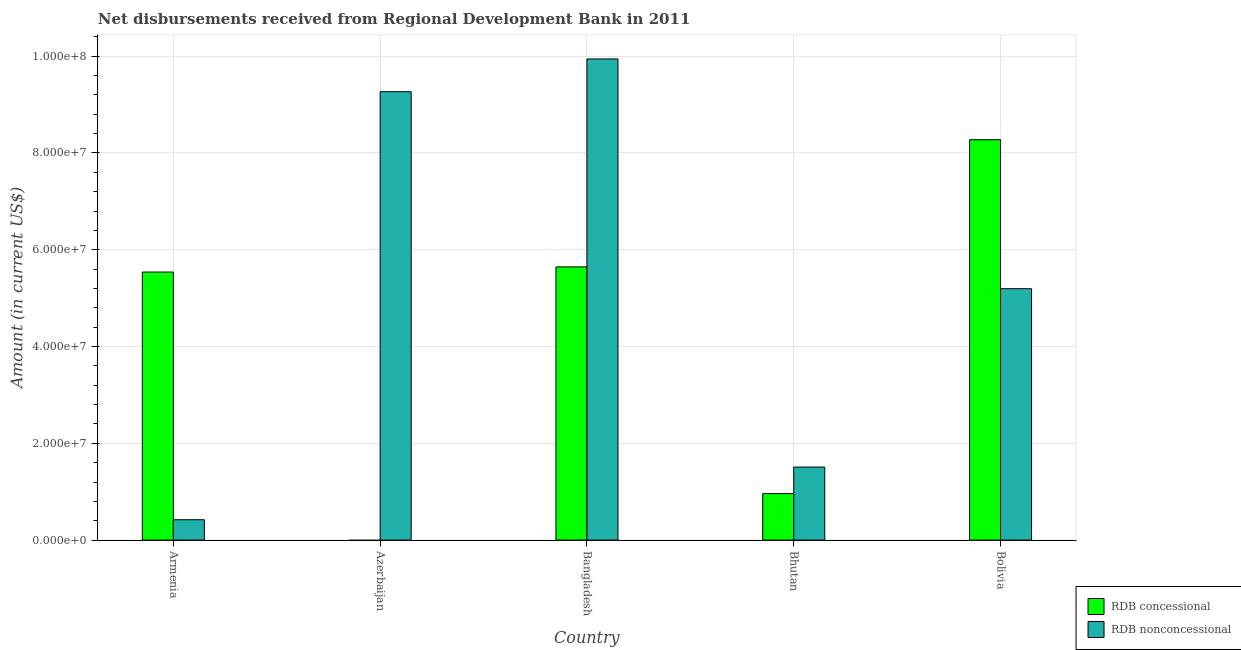How many different coloured bars are there?
Keep it short and to the point. 2. Are the number of bars per tick equal to the number of legend labels?
Your response must be concise. No. Are the number of bars on each tick of the X-axis equal?
Ensure brevity in your answer.  No. What is the label of the 2nd group of bars from the left?
Provide a succinct answer. Azerbaijan. In how many cases, is the number of bars for a given country not equal to the number of legend labels?
Ensure brevity in your answer.  1. What is the net concessional disbursements from rdb in Bolivia?
Give a very brief answer. 8.27e+07. Across all countries, what is the maximum net non concessional disbursements from rdb?
Give a very brief answer. 9.94e+07. What is the total net concessional disbursements from rdb in the graph?
Your response must be concise. 2.04e+08. What is the difference between the net concessional disbursements from rdb in Armenia and that in Bangladesh?
Ensure brevity in your answer.  -1.06e+06. What is the difference between the net non concessional disbursements from rdb in Bolivia and the net concessional disbursements from rdb in Bhutan?
Your answer should be compact. 4.23e+07. What is the average net concessional disbursements from rdb per country?
Give a very brief answer. 4.08e+07. What is the difference between the net concessional disbursements from rdb and net non concessional disbursements from rdb in Bolivia?
Your answer should be very brief. 3.08e+07. In how many countries, is the net non concessional disbursements from rdb greater than 96000000 US$?
Give a very brief answer. 1. What is the ratio of the net non concessional disbursements from rdb in Armenia to that in Bolivia?
Ensure brevity in your answer.  0.08. What is the difference between the highest and the second highest net concessional disbursements from rdb?
Ensure brevity in your answer.  2.63e+07. What is the difference between the highest and the lowest net non concessional disbursements from rdb?
Make the answer very short. 9.52e+07. In how many countries, is the net non concessional disbursements from rdb greater than the average net non concessional disbursements from rdb taken over all countries?
Make the answer very short. 2. Is the sum of the net concessional disbursements from rdb in Armenia and Bhutan greater than the maximum net non concessional disbursements from rdb across all countries?
Provide a short and direct response. No. How many bars are there?
Offer a very short reply. 9. What is the difference between two consecutive major ticks on the Y-axis?
Offer a very short reply. 2.00e+07. Does the graph contain any zero values?
Your response must be concise. Yes. Where does the legend appear in the graph?
Give a very brief answer. Bottom right. What is the title of the graph?
Give a very brief answer. Net disbursements received from Regional Development Bank in 2011. Does "Age 15+" appear as one of the legend labels in the graph?
Your answer should be compact. No. What is the label or title of the X-axis?
Ensure brevity in your answer.  Country. What is the Amount (in current US$) in RDB concessional in Armenia?
Provide a succinct answer. 5.54e+07. What is the Amount (in current US$) in RDB nonconcessional in Armenia?
Provide a short and direct response. 4.21e+06. What is the Amount (in current US$) of RDB nonconcessional in Azerbaijan?
Make the answer very short. 9.27e+07. What is the Amount (in current US$) in RDB concessional in Bangladesh?
Give a very brief answer. 5.64e+07. What is the Amount (in current US$) of RDB nonconcessional in Bangladesh?
Offer a terse response. 9.94e+07. What is the Amount (in current US$) of RDB concessional in Bhutan?
Make the answer very short. 9.62e+06. What is the Amount (in current US$) of RDB nonconcessional in Bhutan?
Your answer should be compact. 1.51e+07. What is the Amount (in current US$) of RDB concessional in Bolivia?
Your response must be concise. 8.27e+07. What is the Amount (in current US$) in RDB nonconcessional in Bolivia?
Provide a short and direct response. 5.19e+07. Across all countries, what is the maximum Amount (in current US$) in RDB concessional?
Provide a succinct answer. 8.27e+07. Across all countries, what is the maximum Amount (in current US$) of RDB nonconcessional?
Your response must be concise. 9.94e+07. Across all countries, what is the minimum Amount (in current US$) in RDB nonconcessional?
Provide a short and direct response. 4.21e+06. What is the total Amount (in current US$) in RDB concessional in the graph?
Provide a succinct answer. 2.04e+08. What is the total Amount (in current US$) in RDB nonconcessional in the graph?
Your response must be concise. 2.63e+08. What is the difference between the Amount (in current US$) of RDB nonconcessional in Armenia and that in Azerbaijan?
Offer a very short reply. -8.84e+07. What is the difference between the Amount (in current US$) in RDB concessional in Armenia and that in Bangladesh?
Keep it short and to the point. -1.06e+06. What is the difference between the Amount (in current US$) in RDB nonconcessional in Armenia and that in Bangladesh?
Give a very brief answer. -9.52e+07. What is the difference between the Amount (in current US$) in RDB concessional in Armenia and that in Bhutan?
Keep it short and to the point. 4.58e+07. What is the difference between the Amount (in current US$) of RDB nonconcessional in Armenia and that in Bhutan?
Your answer should be compact. -1.09e+07. What is the difference between the Amount (in current US$) in RDB concessional in Armenia and that in Bolivia?
Ensure brevity in your answer.  -2.73e+07. What is the difference between the Amount (in current US$) of RDB nonconcessional in Armenia and that in Bolivia?
Keep it short and to the point. -4.77e+07. What is the difference between the Amount (in current US$) in RDB nonconcessional in Azerbaijan and that in Bangladesh?
Your response must be concise. -6.76e+06. What is the difference between the Amount (in current US$) of RDB nonconcessional in Azerbaijan and that in Bhutan?
Keep it short and to the point. 7.76e+07. What is the difference between the Amount (in current US$) in RDB nonconcessional in Azerbaijan and that in Bolivia?
Your answer should be compact. 4.07e+07. What is the difference between the Amount (in current US$) in RDB concessional in Bangladesh and that in Bhutan?
Your response must be concise. 4.68e+07. What is the difference between the Amount (in current US$) in RDB nonconcessional in Bangladesh and that in Bhutan?
Provide a succinct answer. 8.43e+07. What is the difference between the Amount (in current US$) in RDB concessional in Bangladesh and that in Bolivia?
Provide a short and direct response. -2.63e+07. What is the difference between the Amount (in current US$) of RDB nonconcessional in Bangladesh and that in Bolivia?
Provide a succinct answer. 4.75e+07. What is the difference between the Amount (in current US$) in RDB concessional in Bhutan and that in Bolivia?
Provide a short and direct response. -7.31e+07. What is the difference between the Amount (in current US$) of RDB nonconcessional in Bhutan and that in Bolivia?
Offer a very short reply. -3.69e+07. What is the difference between the Amount (in current US$) of RDB concessional in Armenia and the Amount (in current US$) of RDB nonconcessional in Azerbaijan?
Provide a short and direct response. -3.73e+07. What is the difference between the Amount (in current US$) of RDB concessional in Armenia and the Amount (in current US$) of RDB nonconcessional in Bangladesh?
Offer a very short reply. -4.40e+07. What is the difference between the Amount (in current US$) in RDB concessional in Armenia and the Amount (in current US$) in RDB nonconcessional in Bhutan?
Your answer should be compact. 4.03e+07. What is the difference between the Amount (in current US$) of RDB concessional in Armenia and the Amount (in current US$) of RDB nonconcessional in Bolivia?
Your answer should be compact. 3.44e+06. What is the difference between the Amount (in current US$) in RDB concessional in Bangladesh and the Amount (in current US$) in RDB nonconcessional in Bhutan?
Ensure brevity in your answer.  4.14e+07. What is the difference between the Amount (in current US$) of RDB concessional in Bangladesh and the Amount (in current US$) of RDB nonconcessional in Bolivia?
Your answer should be very brief. 4.50e+06. What is the difference between the Amount (in current US$) of RDB concessional in Bhutan and the Amount (in current US$) of RDB nonconcessional in Bolivia?
Offer a terse response. -4.23e+07. What is the average Amount (in current US$) of RDB concessional per country?
Your response must be concise. 4.08e+07. What is the average Amount (in current US$) in RDB nonconcessional per country?
Your answer should be compact. 5.27e+07. What is the difference between the Amount (in current US$) of RDB concessional and Amount (in current US$) of RDB nonconcessional in Armenia?
Offer a terse response. 5.12e+07. What is the difference between the Amount (in current US$) of RDB concessional and Amount (in current US$) of RDB nonconcessional in Bangladesh?
Offer a very short reply. -4.30e+07. What is the difference between the Amount (in current US$) of RDB concessional and Amount (in current US$) of RDB nonconcessional in Bhutan?
Make the answer very short. -5.48e+06. What is the difference between the Amount (in current US$) in RDB concessional and Amount (in current US$) in RDB nonconcessional in Bolivia?
Your answer should be compact. 3.08e+07. What is the ratio of the Amount (in current US$) in RDB nonconcessional in Armenia to that in Azerbaijan?
Provide a short and direct response. 0.05. What is the ratio of the Amount (in current US$) of RDB concessional in Armenia to that in Bangladesh?
Your answer should be very brief. 0.98. What is the ratio of the Amount (in current US$) of RDB nonconcessional in Armenia to that in Bangladesh?
Make the answer very short. 0.04. What is the ratio of the Amount (in current US$) in RDB concessional in Armenia to that in Bhutan?
Your answer should be very brief. 5.76. What is the ratio of the Amount (in current US$) in RDB nonconcessional in Armenia to that in Bhutan?
Provide a succinct answer. 0.28. What is the ratio of the Amount (in current US$) of RDB concessional in Armenia to that in Bolivia?
Give a very brief answer. 0.67. What is the ratio of the Amount (in current US$) in RDB nonconcessional in Armenia to that in Bolivia?
Your answer should be compact. 0.08. What is the ratio of the Amount (in current US$) of RDB nonconcessional in Azerbaijan to that in Bangladesh?
Ensure brevity in your answer.  0.93. What is the ratio of the Amount (in current US$) in RDB nonconcessional in Azerbaijan to that in Bhutan?
Ensure brevity in your answer.  6.14. What is the ratio of the Amount (in current US$) of RDB nonconcessional in Azerbaijan to that in Bolivia?
Provide a short and direct response. 1.78. What is the ratio of the Amount (in current US$) of RDB concessional in Bangladesh to that in Bhutan?
Provide a short and direct response. 5.87. What is the ratio of the Amount (in current US$) of RDB nonconcessional in Bangladesh to that in Bhutan?
Your answer should be very brief. 6.59. What is the ratio of the Amount (in current US$) of RDB concessional in Bangladesh to that in Bolivia?
Your answer should be very brief. 0.68. What is the ratio of the Amount (in current US$) in RDB nonconcessional in Bangladesh to that in Bolivia?
Provide a short and direct response. 1.91. What is the ratio of the Amount (in current US$) in RDB concessional in Bhutan to that in Bolivia?
Your answer should be very brief. 0.12. What is the ratio of the Amount (in current US$) in RDB nonconcessional in Bhutan to that in Bolivia?
Ensure brevity in your answer.  0.29. What is the difference between the highest and the second highest Amount (in current US$) of RDB concessional?
Provide a short and direct response. 2.63e+07. What is the difference between the highest and the second highest Amount (in current US$) in RDB nonconcessional?
Provide a succinct answer. 6.76e+06. What is the difference between the highest and the lowest Amount (in current US$) of RDB concessional?
Offer a very short reply. 8.27e+07. What is the difference between the highest and the lowest Amount (in current US$) of RDB nonconcessional?
Provide a short and direct response. 9.52e+07. 